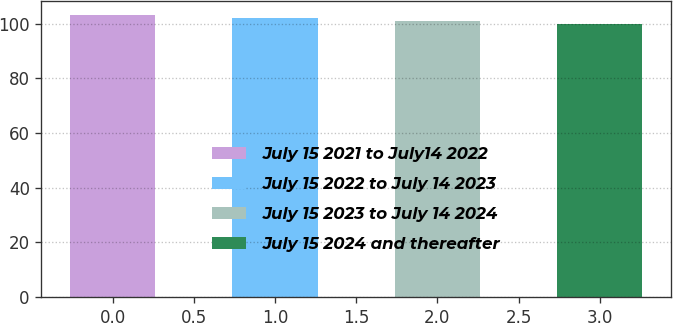Convert chart to OTSL. <chart><loc_0><loc_0><loc_500><loc_500><bar_chart><fcel>July 15 2021 to July14 2022<fcel>July 15 2022 to July 14 2023<fcel>July 15 2023 to July 14 2024<fcel>July 15 2024 and thereafter<nl><fcel>103.31<fcel>102.21<fcel>101.1<fcel>100<nl></chart> 